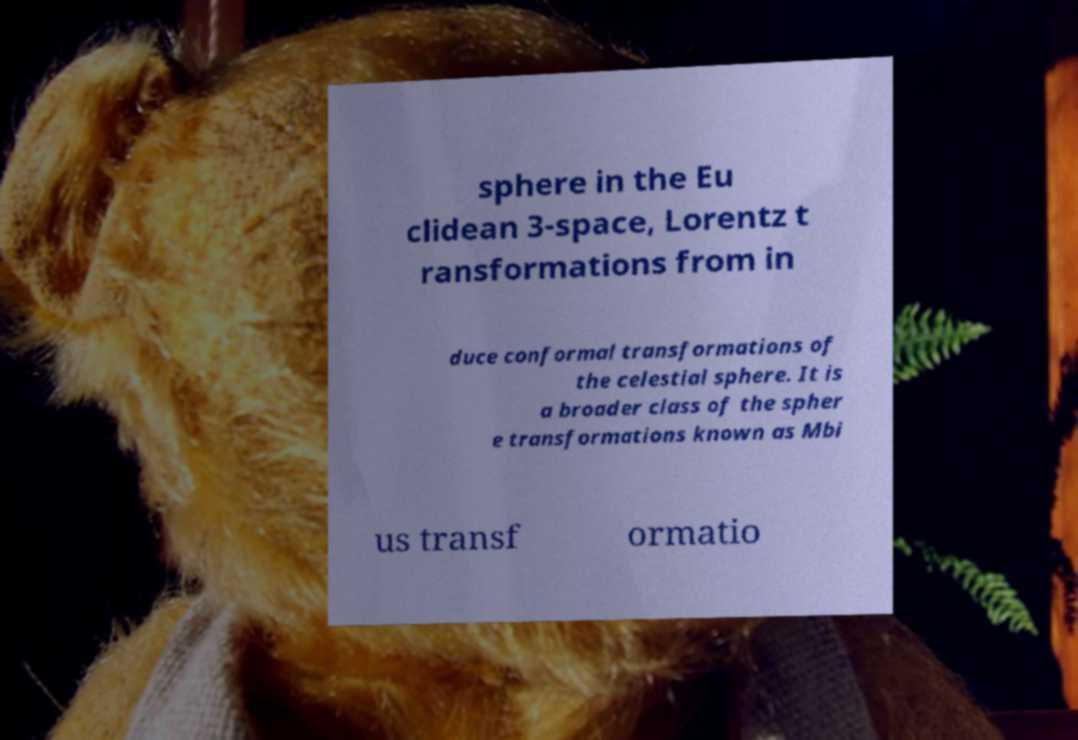I need the written content from this picture converted into text. Can you do that? sphere in the Eu clidean 3-space, Lorentz t ransformations from in duce conformal transformations of the celestial sphere. It is a broader class of the spher e transformations known as Mbi us transf ormatio 